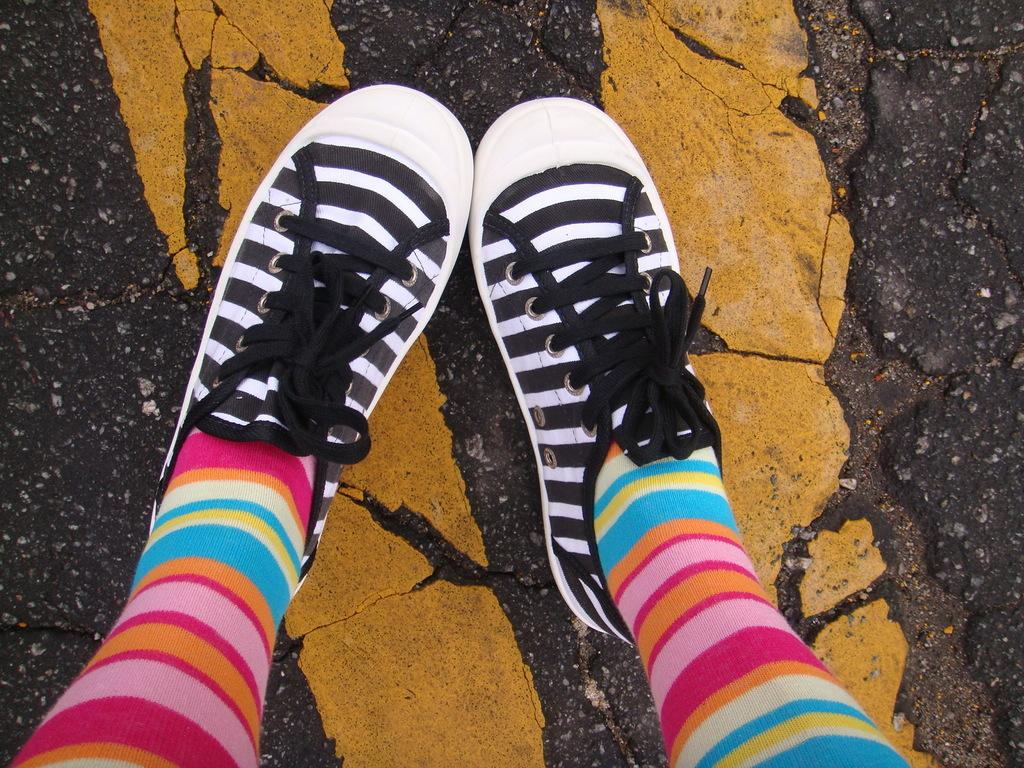What part of a person can be seen in the image? There are legs of a person in the image. What type of footwear is the person wearing? The person is wearing shoes. What type of surface is visible in the image? There is a road in the image. What type of medical advice is the doctor giving to the kitty in the image? There is no doctor or kitty present in the image. What type of trade is being conducted on the road in the image? There is no trade being conducted in the image; it only shows a road and the legs of a person. 